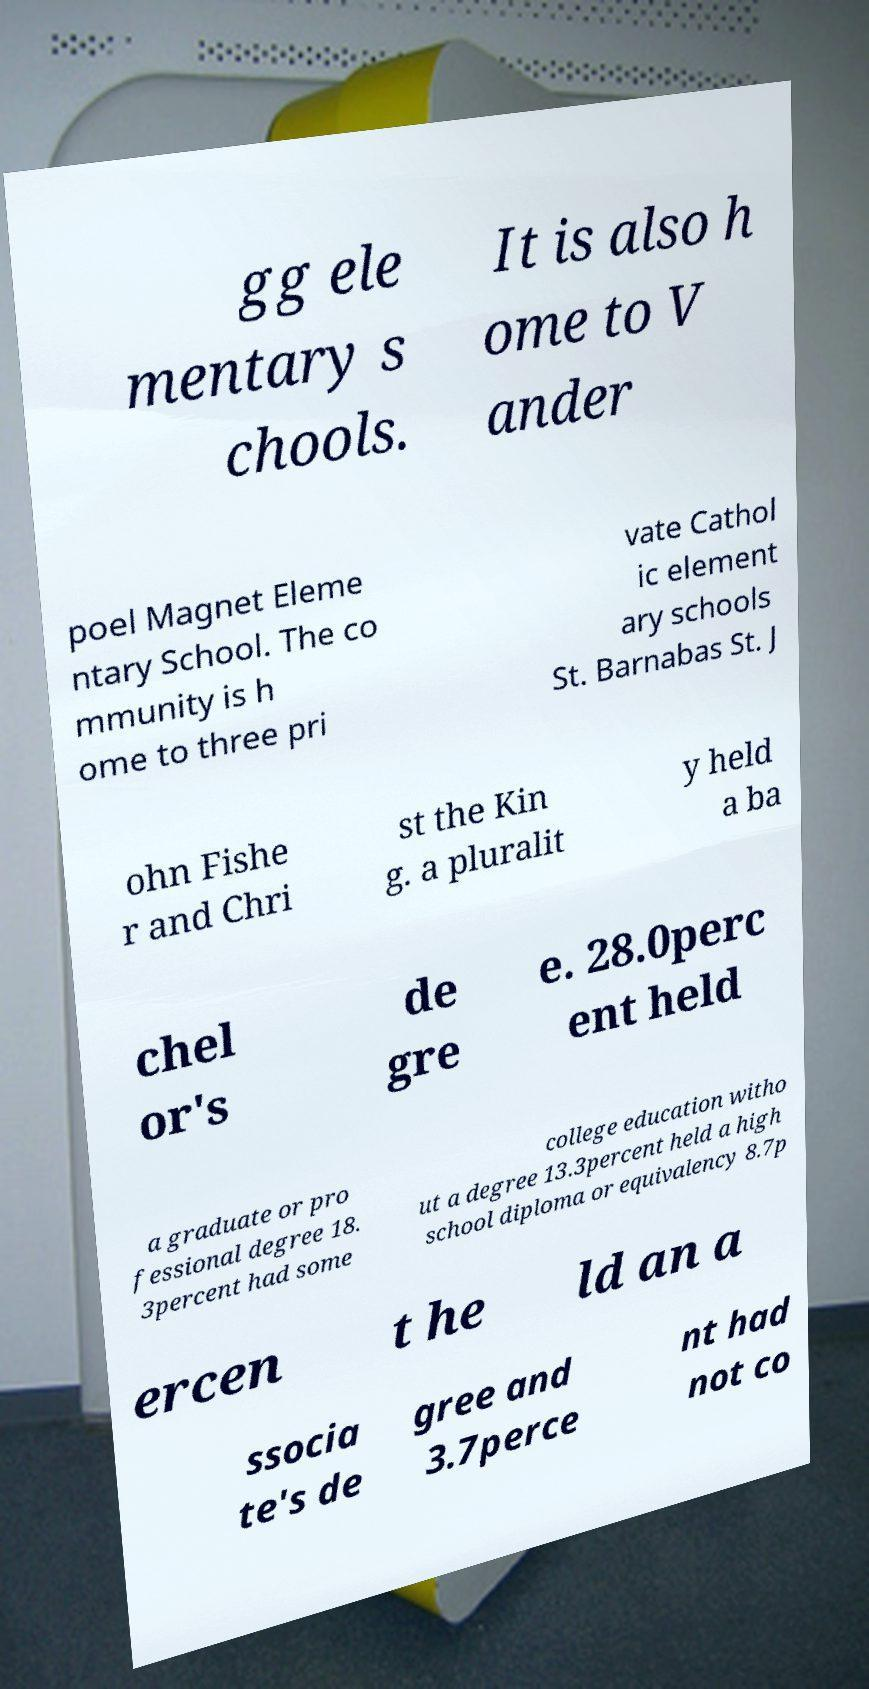What messages or text are displayed in this image? I need them in a readable, typed format. gg ele mentary s chools. It is also h ome to V ander poel Magnet Eleme ntary School. The co mmunity is h ome to three pri vate Cathol ic element ary schools St. Barnabas St. J ohn Fishe r and Chri st the Kin g. a pluralit y held a ba chel or's de gre e. 28.0perc ent held a graduate or pro fessional degree 18. 3percent had some college education witho ut a degree 13.3percent held a high school diploma or equivalency 8.7p ercen t he ld an a ssocia te's de gree and 3.7perce nt had not co 